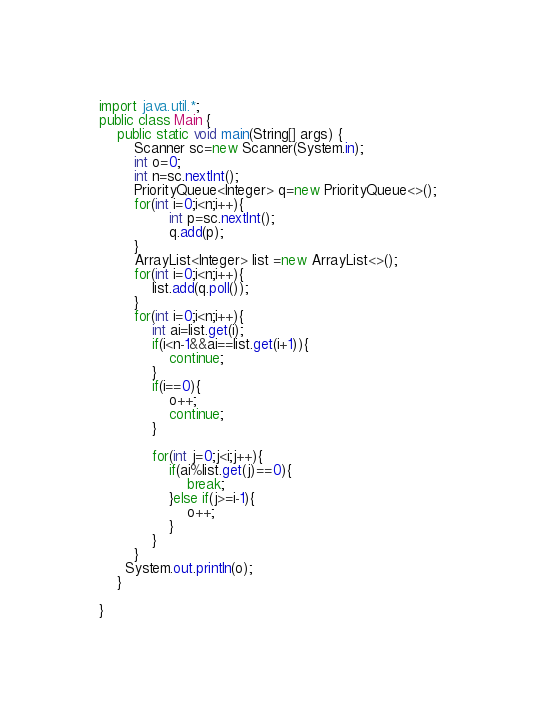Convert code to text. <code><loc_0><loc_0><loc_500><loc_500><_Java_>import java.util.*;
public class Main { 
    public static void main(String[] args) {
        Scanner sc=new Scanner(System.in);
        int o=0;
        int n=sc.nextInt();
        PriorityQueue<Integer> q=new PriorityQueue<>();
		for(int i=0;i<n;i++){
        		int p=sc.nextInt();
        		q.add(p);
		}
      	ArrayList<Integer> list =new ArrayList<>();
      	for(int i=0;i<n;i++){
        	list.add(q.poll());
		}
      	for(int i=0;i<n;i++){
          	int ai=list.get(i);
          	if(i<n-1&&ai==list.get(i+1)){
            	continue;
            }
          	if(i==0){
            	o++;
              	continue;
            }
          	
        	for(int j=0;j<i;j++){
            	if(ai%list.get(j)==0){
                	break;
                }else if(j>=i-1){
                	o++;
                }
            }
        }
      System.out.println(o);
    }
    
}</code> 